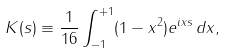<formula> <loc_0><loc_0><loc_500><loc_500>K ( s ) \equiv \frac { 1 } { 1 6 } \int _ { - 1 } ^ { + 1 } ( 1 - x ^ { 2 } ) e ^ { i x s } \, d x ,</formula> 